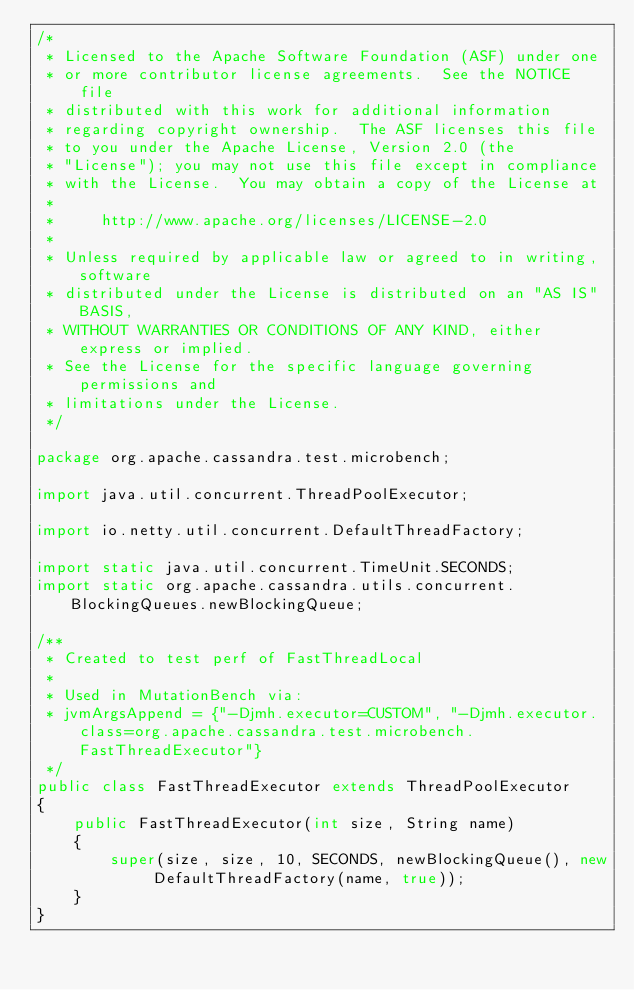Convert code to text. <code><loc_0><loc_0><loc_500><loc_500><_Java_>/*
 * Licensed to the Apache Software Foundation (ASF) under one
 * or more contributor license agreements.  See the NOTICE file
 * distributed with this work for additional information
 * regarding copyright ownership.  The ASF licenses this file
 * to you under the Apache License, Version 2.0 (the
 * "License"); you may not use this file except in compliance
 * with the License.  You may obtain a copy of the License at
 *
 *     http://www.apache.org/licenses/LICENSE-2.0
 *
 * Unless required by applicable law or agreed to in writing, software
 * distributed under the License is distributed on an "AS IS" BASIS,
 * WITHOUT WARRANTIES OR CONDITIONS OF ANY KIND, either express or implied.
 * See the License for the specific language governing permissions and
 * limitations under the License.
 */

package org.apache.cassandra.test.microbench;

import java.util.concurrent.ThreadPoolExecutor;

import io.netty.util.concurrent.DefaultThreadFactory;

import static java.util.concurrent.TimeUnit.SECONDS;
import static org.apache.cassandra.utils.concurrent.BlockingQueues.newBlockingQueue;

/**
 * Created to test perf of FastThreadLocal
 *
 * Used in MutationBench via:
 * jvmArgsAppend = {"-Djmh.executor=CUSTOM", "-Djmh.executor.class=org.apache.cassandra.test.microbench.FastThreadExecutor"}
 */
public class FastThreadExecutor extends ThreadPoolExecutor
{
    public FastThreadExecutor(int size, String name)
    {
        super(size, size, 10, SECONDS, newBlockingQueue(), new DefaultThreadFactory(name, true));
    }
}
</code> 